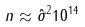Convert formula to latex. <formula><loc_0><loc_0><loc_500><loc_500>n \approx \hat { \sigma } ^ { 2 } 1 0 ^ { 1 4 }</formula> 